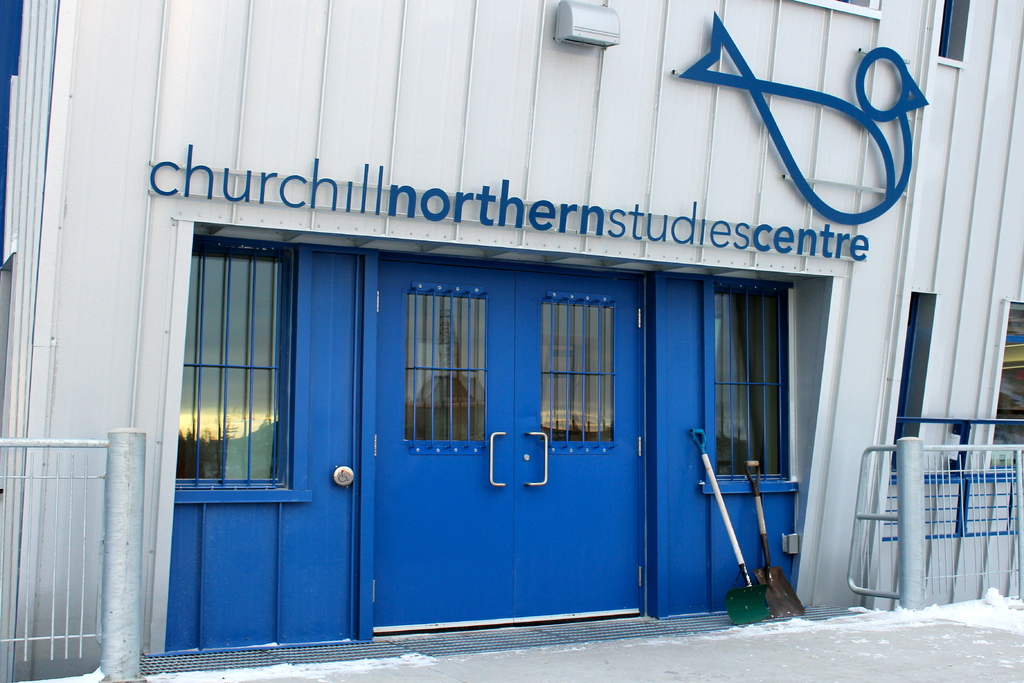What kind of research is conducted at the Churchill Northern Studies Centre? The Churchill Northern Studies Centre focuses on a variety of research areas primarily related to sub-arctic and arctic ecosystems. This includes studies on climate change, aurora borealis, polar bear behavior, and the impact of environmental changes on arctic wildlife. The facility serves as a hub for scientists and students from around the globe, providing a base for fieldwork and environmental monitoring. 